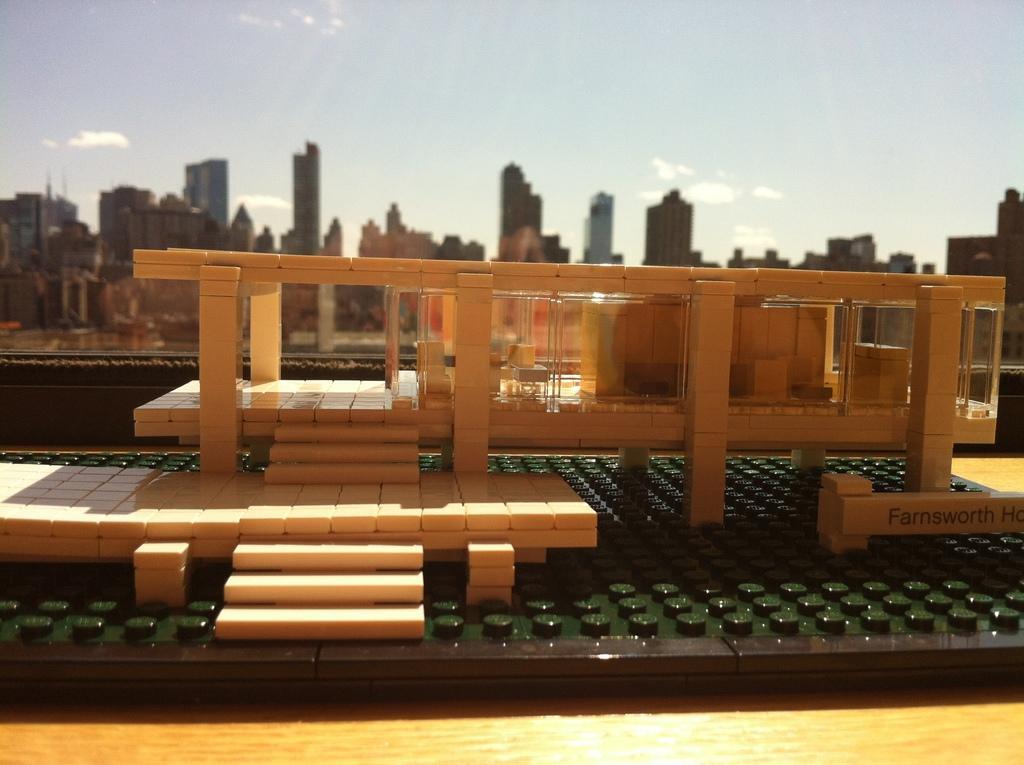Can you describe this image briefly? In this picture we can see a miniature building on the wooden platform. In the background we can see the glass, buildings and the sky. 